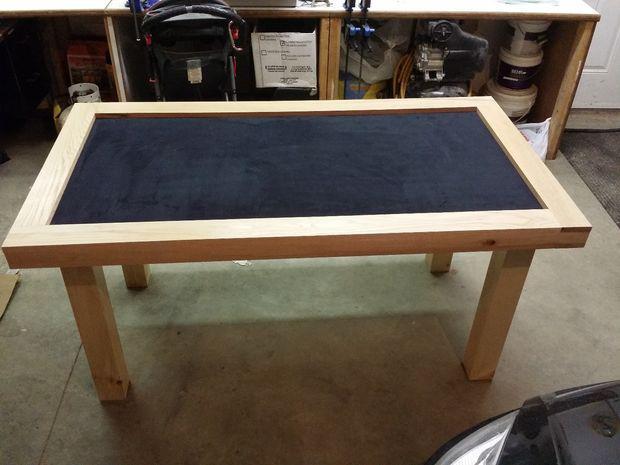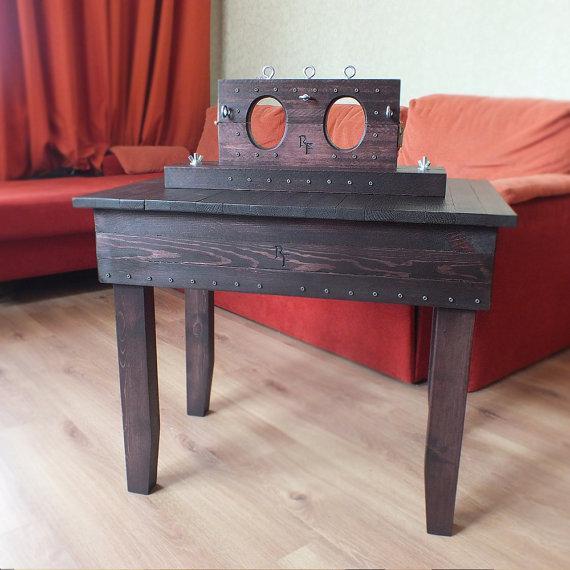The first image is the image on the left, the second image is the image on the right. Assess this claim about the two images: "An image shows a rectangular table with wood border, charcoal center, and no chairs.". Correct or not? Answer yes or no. Yes. The first image is the image on the left, the second image is the image on the right. Examine the images to the left and right. Is the description "In one image, a rectangular table has chairs at each side and at each end." accurate? Answer yes or no. No. 